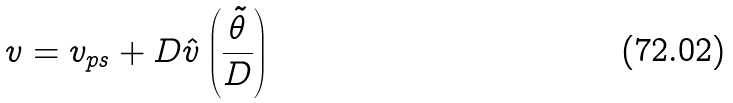Convert formula to latex. <formula><loc_0><loc_0><loc_500><loc_500>v = v _ { p s } + D \hat { v } \left ( \frac { \tilde { \theta } } { D } \right )</formula> 